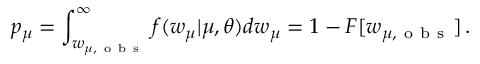Convert formula to latex. <formula><loc_0><loc_0><loc_500><loc_500>p _ { \mu } = \int _ { w _ { \mu , o b s } } ^ { \infty } f ( w _ { \mu } | \mu , \theta ) d w _ { \mu } = 1 - F [ w _ { \mu , o b s } ] \, .</formula> 